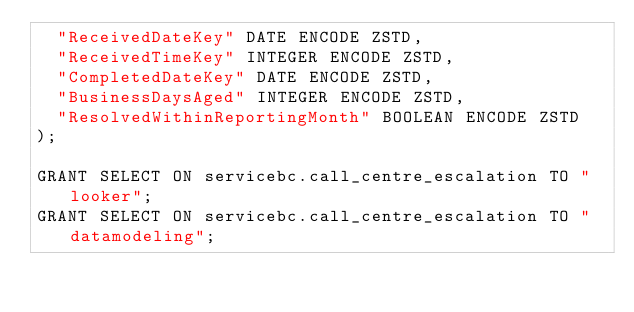Convert code to text. <code><loc_0><loc_0><loc_500><loc_500><_SQL_>  "ReceivedDateKey" DATE ENCODE ZSTD,
  "ReceivedTimeKey" INTEGER ENCODE ZSTD,
  "CompletedDateKey" DATE ENCODE ZSTD,
  "BusinessDaysAged" INTEGER ENCODE ZSTD,
  "ResolvedWithinReportingMonth" BOOLEAN ENCODE ZSTD
);

GRANT SELECT ON servicebc.call_centre_escalation TO "looker";
GRANT SELECT ON servicebc.call_centre_escalation TO "datamodeling";
</code> 